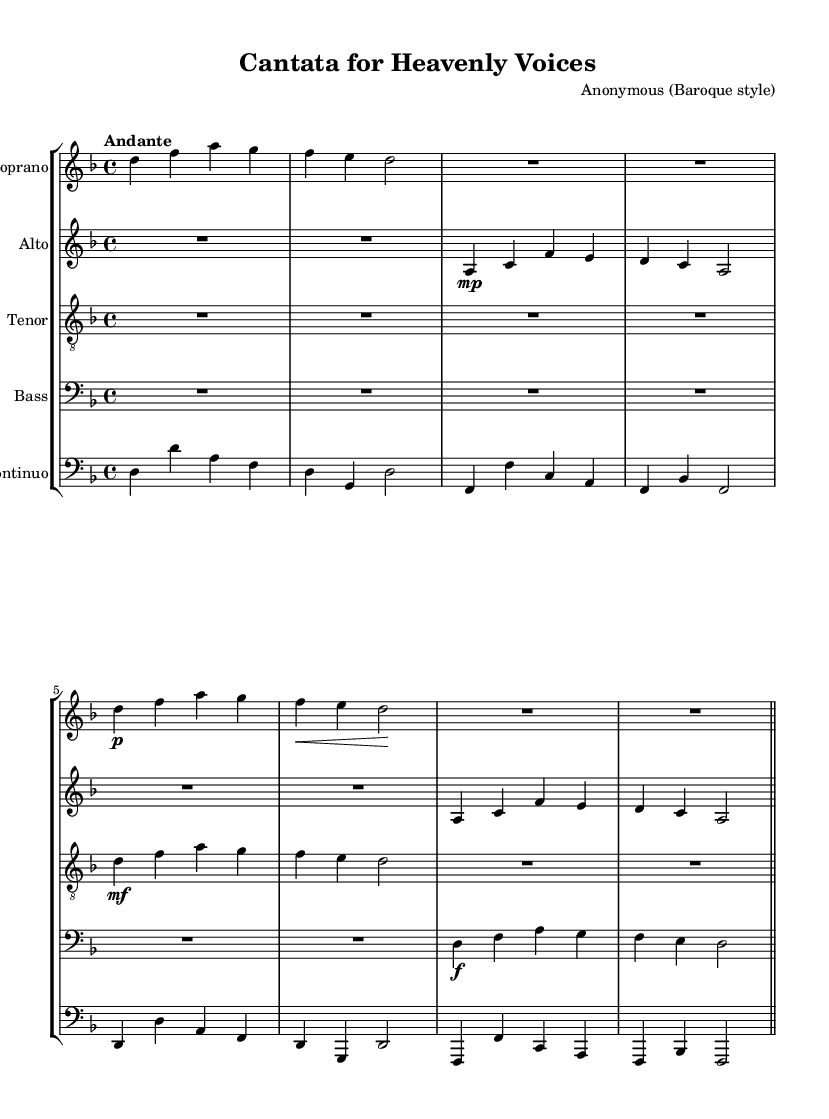What is the key signature of this music? The key signature is indicated at the beginning of the score with one flat, which corresponds to D minor or F major.
Answer: D minor What is the time signature of this music? The time signature is shown at the start of the piece, indicating how many beats are in each measure. Here, it's 4/4, which means there are four beats per measure.
Answer: 4/4 What is the tempo marking used in this score? The tempo marking is written above the staff and is a directive for the performance speed. In this case, it states "Andante," signifying a moderate pace.
Answer: Andante How many vocal parts are present in this cantata? The score shows separate staves for each vocal part, which includes soprano, alto, tenor, and bass, thus totaling four vocal parts.
Answer: Four Which vocal part has the lowest range? The lowest vocal part is typically the bass, as it is indicated on the bass clef section of the score, which denotes the lower pitches.
Answer: Bass What dynamics are indicated for the soprano part in measure 4? The soprano part features a piano (p) marking in measure 4, indicating that the dynamics should be soft.
Answer: Piano What type of musical texture is primarily used in this choral work? The score displays several voices singing different parts but harmonizing, indicating a polyphonic texture, which is common in Baroque choral music.
Answer: Polyphonic 